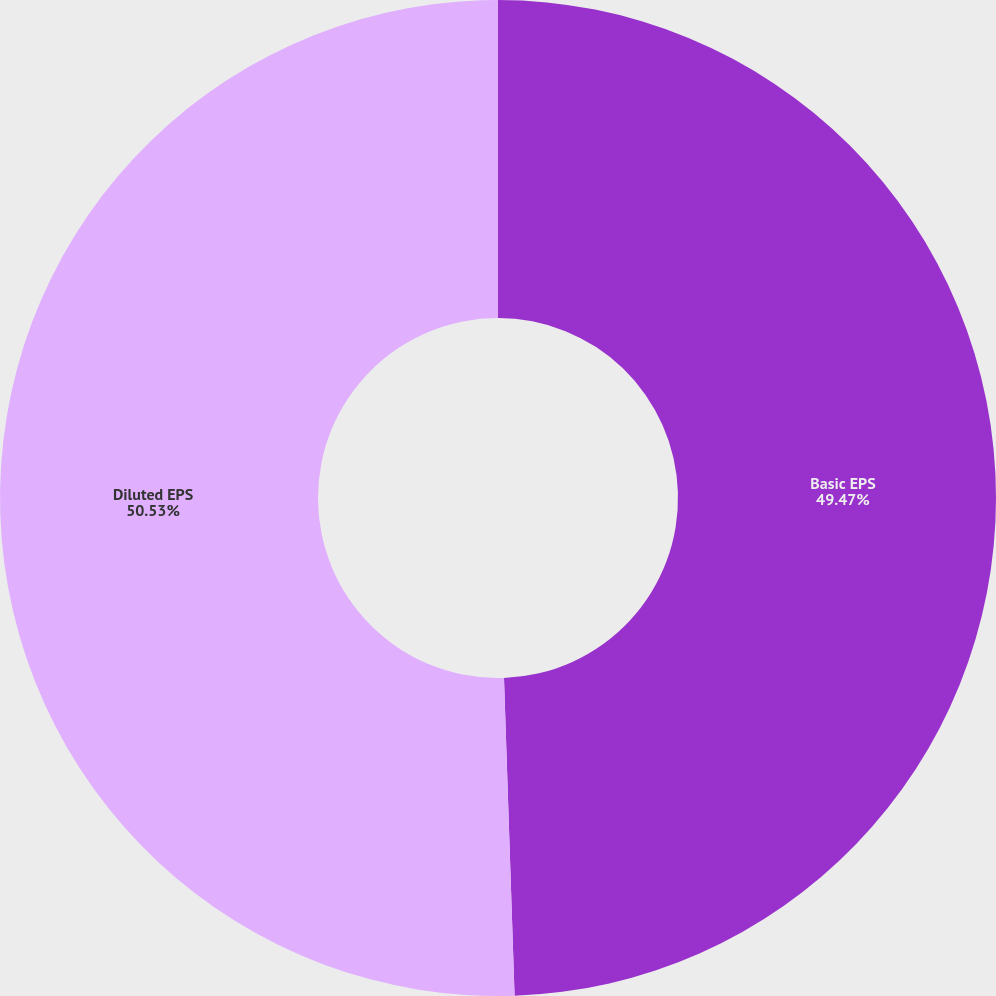<chart> <loc_0><loc_0><loc_500><loc_500><pie_chart><fcel>Basic EPS<fcel>Diluted EPS<nl><fcel>49.47%<fcel>50.53%<nl></chart> 